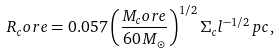<formula> <loc_0><loc_0><loc_500><loc_500>R _ { c } o r e = 0 . 0 5 7 \left ( \frac { M _ { c } o r e } { 6 0 \, M _ { \odot } } \right ) ^ { 1 / 2 } \Sigma _ { c } l ^ { - 1 / 2 } \, p c ,</formula> 